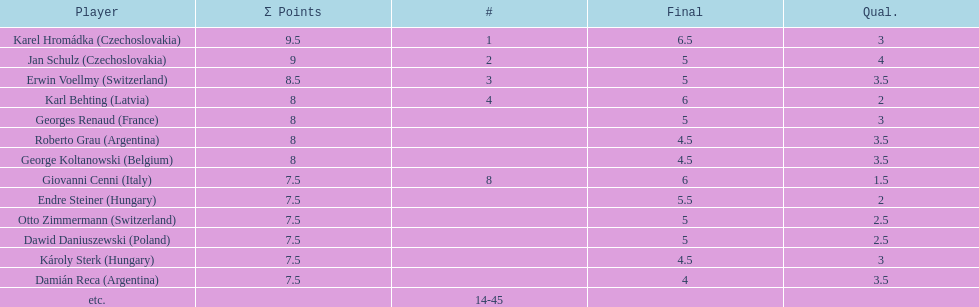How many players had final scores higher than 5? 4. 